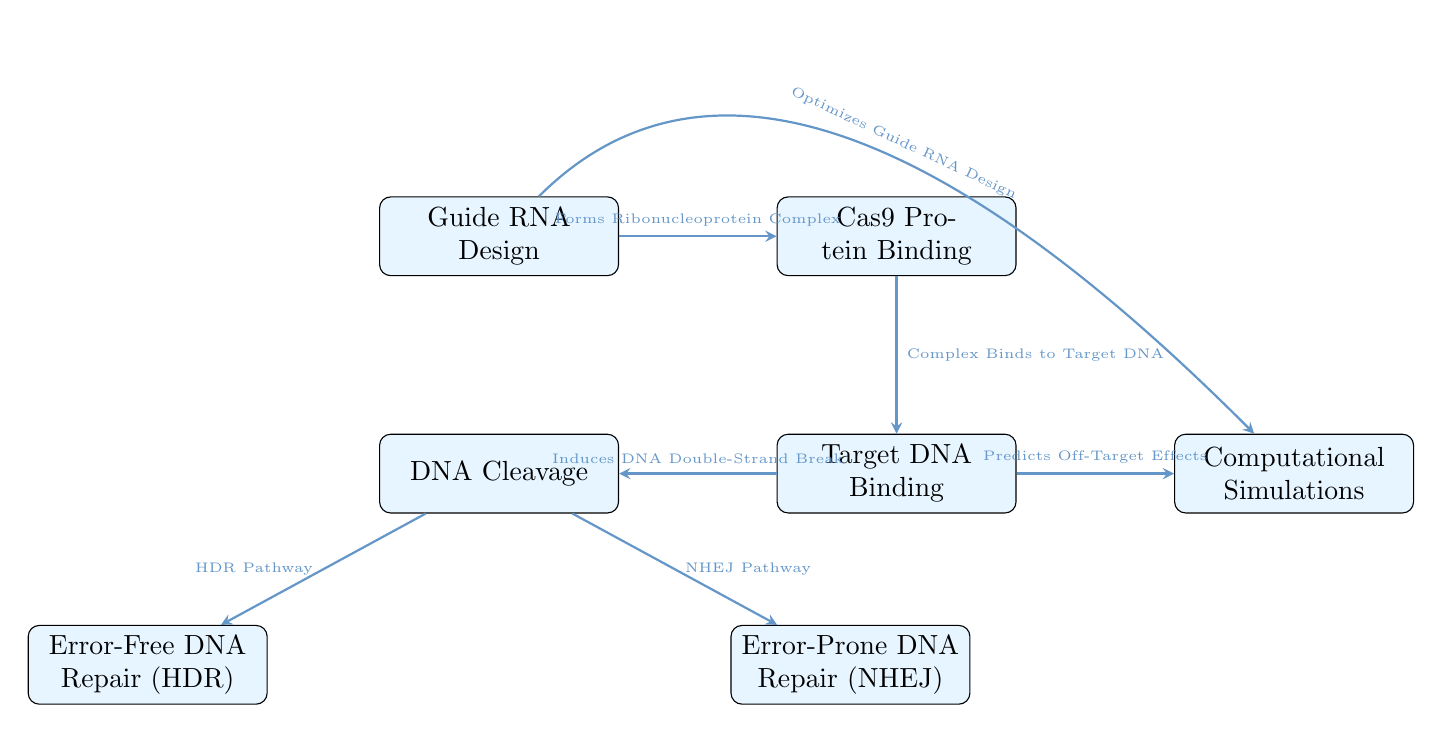What is the first step in the CRISPR-Cas9 mechanism? The first step in the CRISPR-Cas9 mechanism is "Guide RNA Design," which is clearly depicted at the top of the diagram as the starting node.
Answer: Guide RNA Design How many pathways are there following DNA cleavage? The diagram indicates there are two pathways after the "DNA Cleavage" node: "Error-Free DNA Repair (HDR)" and "Error-Prone DNA Repair (NHEJ)."
Answer: Two What connection is made after the "Target DNA Binding"? Following "Target DNA Binding," the connection leads to "DNA Cleavage," as indicated by the direct arrow connecting these two processes in the diagram.
Answer: DNA Cleavage Which step involves predicting off-target effects? The step involving predicting off-target effects is "Computational Simulations," as shown by the arrow coming from "Target DNA Binding" that points to this process.
Answer: Computational Simulations In which direction does the "Cas9 Protein Binding" flow? The flow direction of "Cas9 Protein Binding" is to the right, towards "Target DNA Binding," as indicated by the arrow drawn in the diagram.
Answer: Right Which repair mechanism is associated with the HDR pathway? The "Error-Free DNA Repair (HDR)" is associated with the HDR pathway, explicitly labeled in the diagram as the outcome from "DNA Cleavage."
Answer: Error-Free DNA Repair What does the arrow from "Guide RNA Design" to "Computational Simulations" indicate? The arrow indicates an optimization process, specifically that "Guide RNA Design" optimizes the design of guide RNA through computational simulations.
Answer: Optimizes Guide RNA Design What type of protein binds to the guide RNA in the process? The type of protein that binds to the guide RNA is "Cas9 Protein," which is named specifically in the process following "Guide RNA Design."
Answer: Cas9 Protein Which repair mechanism is known for introducing errors? The repair mechanism known for introducing errors is "Error-Prone DNA Repair (NHEJ)," labeled in the diagram as the outcome of one pathway from "DNA Cleavage."
Answer: Error-Prone DNA Repair 